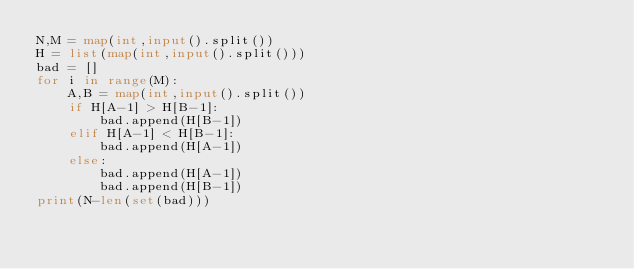Convert code to text. <code><loc_0><loc_0><loc_500><loc_500><_Python_>N,M = map(int,input().split())
H = list(map(int,input().split()))
bad = []
for i in range(M):
    A,B = map(int,input().split())
    if H[A-1] > H[B-1]:
        bad.append(H[B-1])
    elif H[A-1] < H[B-1]:
        bad.append(H[A-1])
    else:
        bad.append(H[A-1])
        bad.append(H[B-1])
print(N-len(set(bad)))</code> 